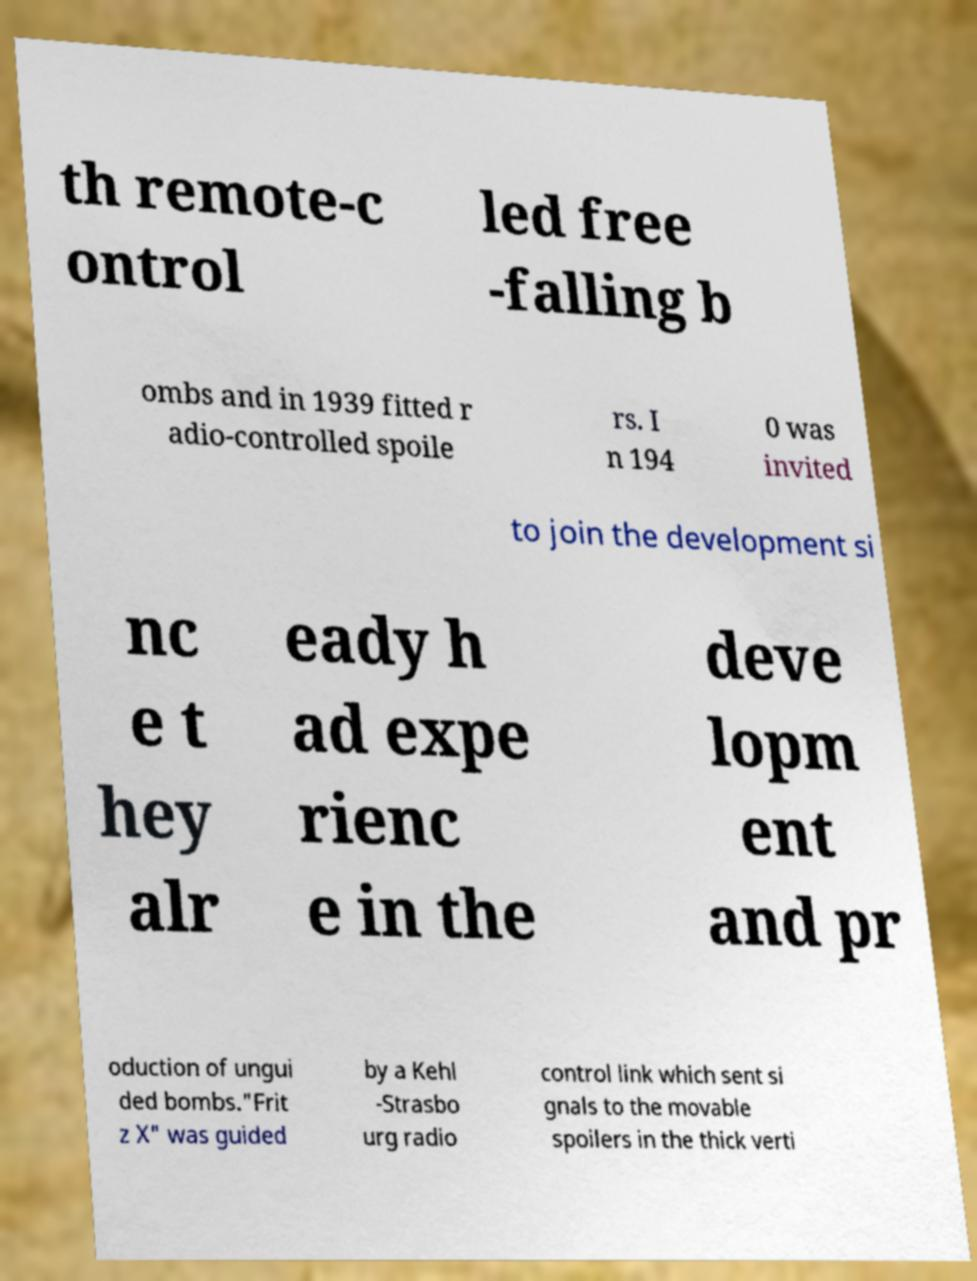Please identify and transcribe the text found in this image. th remote-c ontrol led free -falling b ombs and in 1939 fitted r adio-controlled spoile rs. I n 194 0 was invited to join the development si nc e t hey alr eady h ad expe rienc e in the deve lopm ent and pr oduction of ungui ded bombs."Frit z X" was guided by a Kehl -Strasbo urg radio control link which sent si gnals to the movable spoilers in the thick verti 